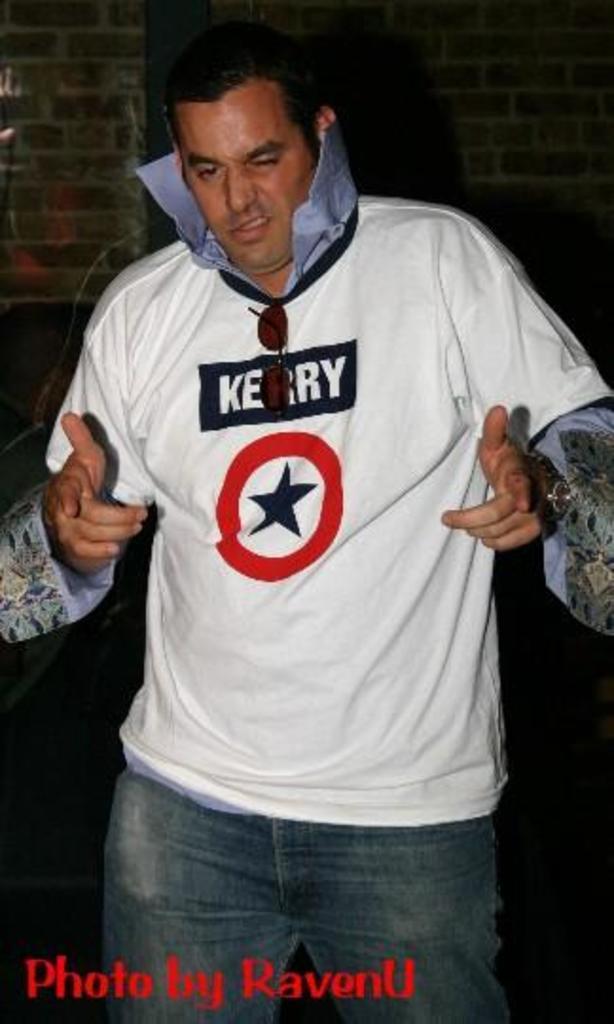Who is the photo by?
Give a very brief answer. Ravenu. What name is written on the shirt?
Provide a short and direct response. Kerry. 